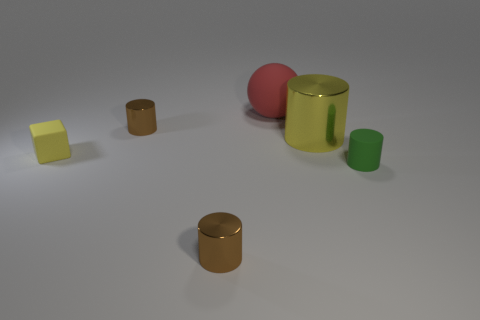Subtract all metallic cylinders. How many cylinders are left? 1 Subtract 0 green blocks. How many objects are left? 6 Subtract all cylinders. How many objects are left? 2 Subtract 1 cubes. How many cubes are left? 0 Subtract all purple balls. Subtract all brown cylinders. How many balls are left? 1 Subtract all yellow spheres. How many cyan blocks are left? 0 Subtract all green cylinders. Subtract all brown things. How many objects are left? 3 Add 6 large red objects. How many large red objects are left? 7 Add 6 big green metallic cylinders. How many big green metallic cylinders exist? 6 Add 2 big yellow shiny things. How many objects exist? 8 